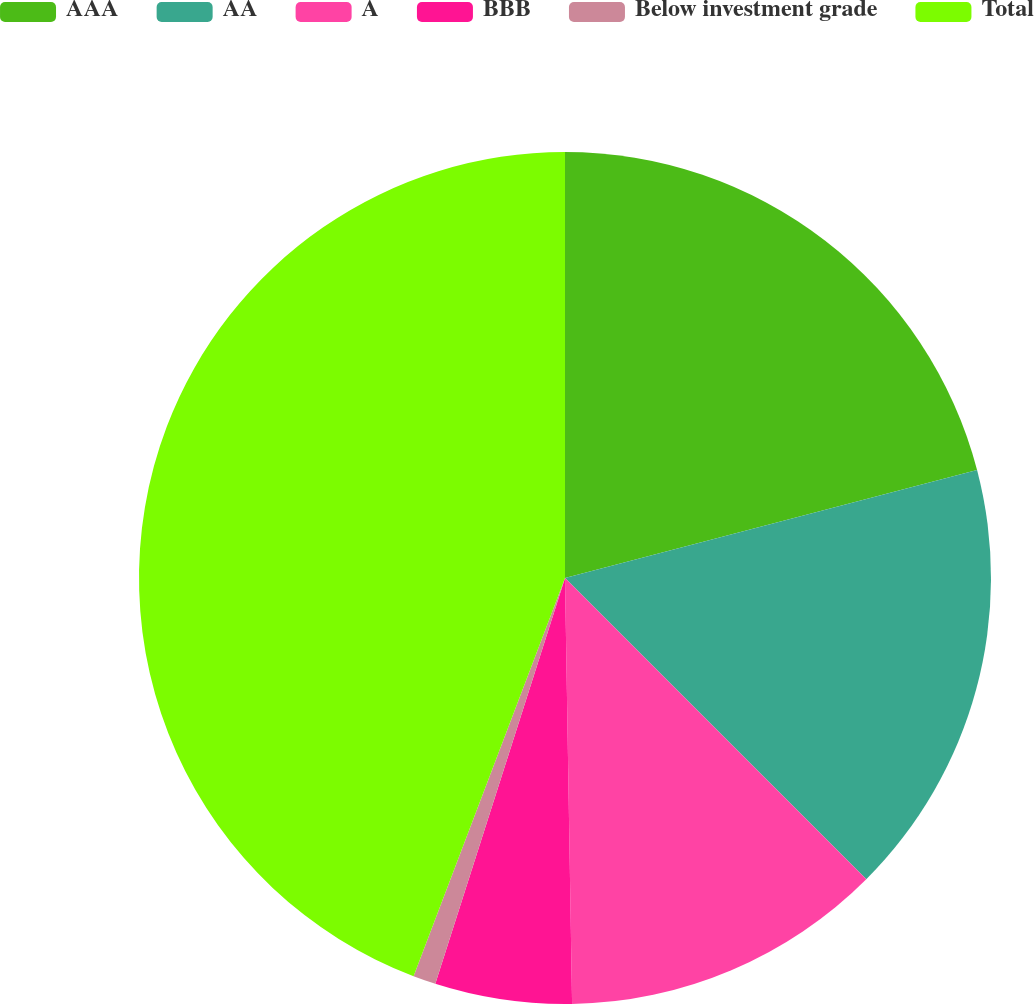Convert chart. <chart><loc_0><loc_0><loc_500><loc_500><pie_chart><fcel>AAA<fcel>AA<fcel>A<fcel>BBB<fcel>Below investment grade<fcel>Total<nl><fcel>20.92%<fcel>16.58%<fcel>12.24%<fcel>5.19%<fcel>0.86%<fcel>44.22%<nl></chart> 